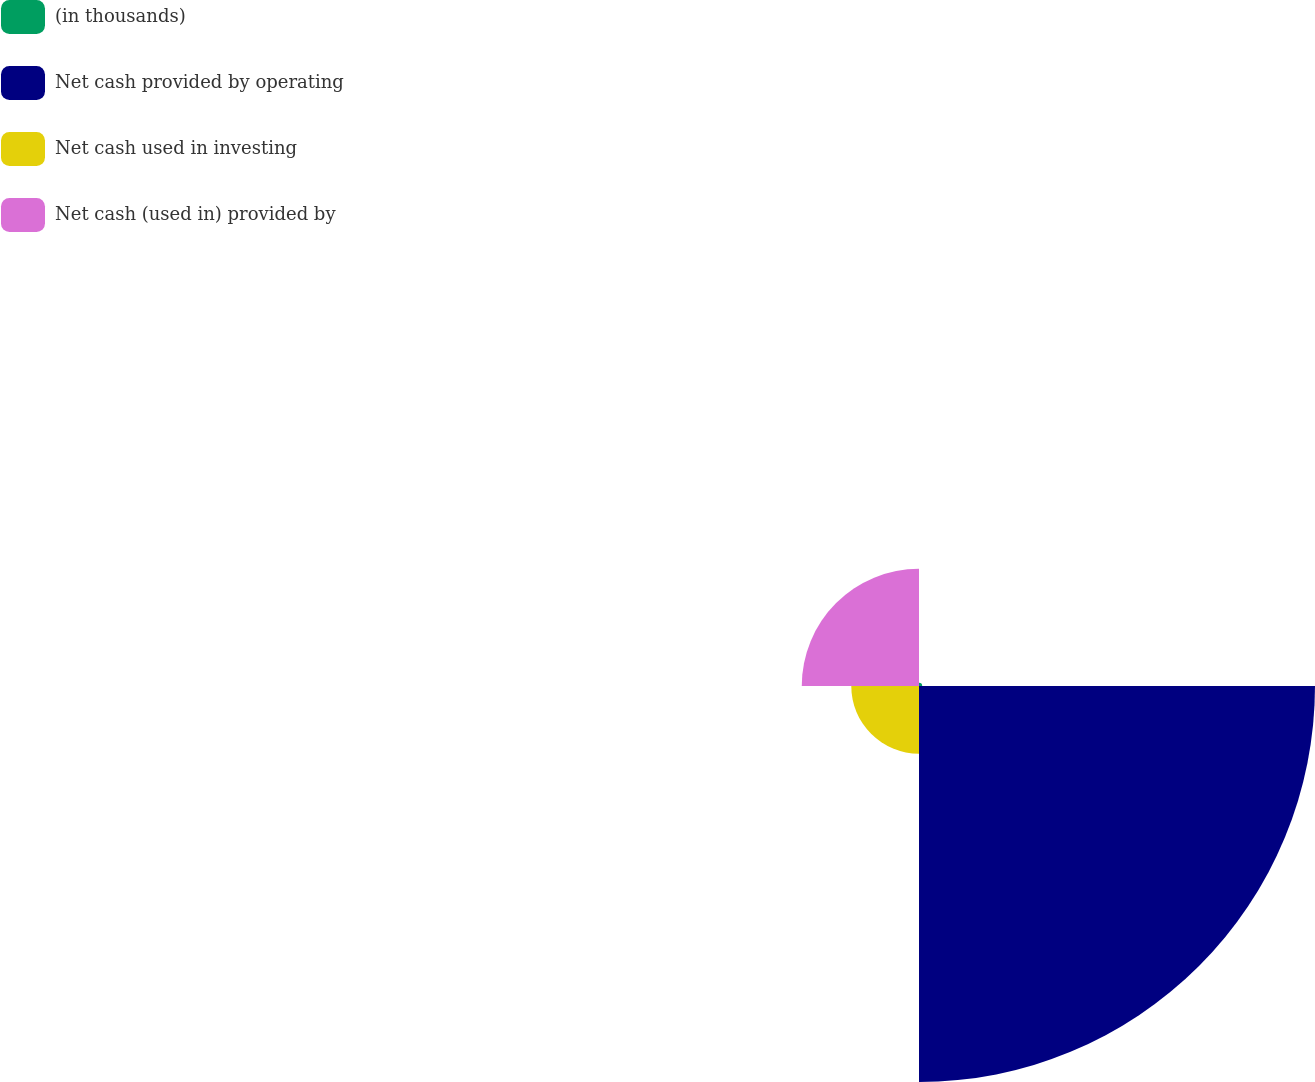Convert chart to OTSL. <chart><loc_0><loc_0><loc_500><loc_500><pie_chart><fcel>(in thousands)<fcel>Net cash provided by operating<fcel>Net cash used in investing<fcel>Net cash (used in) provided by<nl><fcel>0.55%<fcel>67.79%<fcel>11.59%<fcel>20.07%<nl></chart> 